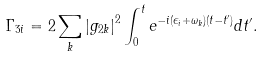<formula> <loc_0><loc_0><loc_500><loc_500>\Gamma _ { 3 i } = 2 \sum _ { k } \left | g _ { 2 k } \right | ^ { 2 } \int ^ { t } _ { 0 } e ^ { - i ( \epsilon _ { i } + \omega _ { k } ) ( t - t ^ { \prime } ) } d t ^ { \prime } .</formula> 